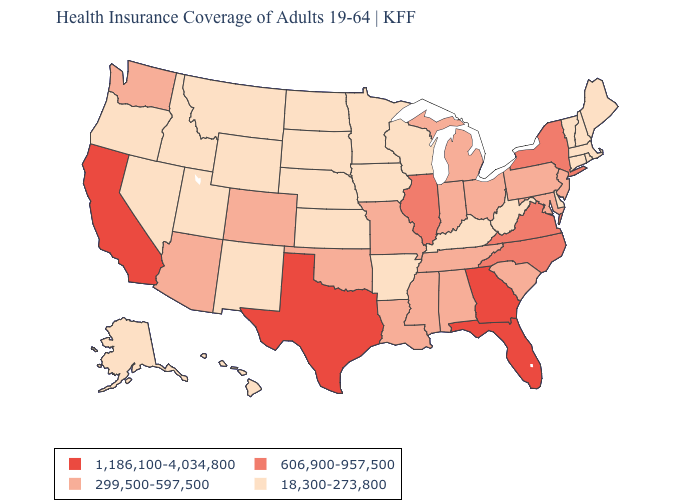Among the states that border Michigan , does Wisconsin have the highest value?
Concise answer only. No. How many symbols are there in the legend?
Answer briefly. 4. Name the states that have a value in the range 1,186,100-4,034,800?
Short answer required. California, Florida, Georgia, Texas. Name the states that have a value in the range 606,900-957,500?
Quick response, please. Illinois, New York, North Carolina, Virginia. Among the states that border Arizona , which have the highest value?
Concise answer only. California. What is the value of Texas?
Concise answer only. 1,186,100-4,034,800. Does the first symbol in the legend represent the smallest category?
Be succinct. No. Name the states that have a value in the range 1,186,100-4,034,800?
Concise answer only. California, Florida, Georgia, Texas. Does the map have missing data?
Write a very short answer. No. Name the states that have a value in the range 1,186,100-4,034,800?
Short answer required. California, Florida, Georgia, Texas. Which states hav the highest value in the Northeast?
Answer briefly. New York. What is the value of South Carolina?
Give a very brief answer. 299,500-597,500. Which states have the highest value in the USA?
Write a very short answer. California, Florida, Georgia, Texas. What is the value of Nevada?
Quick response, please. 18,300-273,800. 